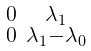Convert formula to latex. <formula><loc_0><loc_0><loc_500><loc_500>\begin{smallmatrix} 0 & \lambda _ { 1 } \\ 0 & \lambda _ { 1 } - \lambda _ { 0 } \\ \end{smallmatrix}</formula> 